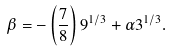Convert formula to latex. <formula><loc_0><loc_0><loc_500><loc_500>\beta = - \left ( \frac { 7 } { 8 } \right ) 9 ^ { 1 / 3 } + \alpha 3 ^ { 1 / 3 } .</formula> 